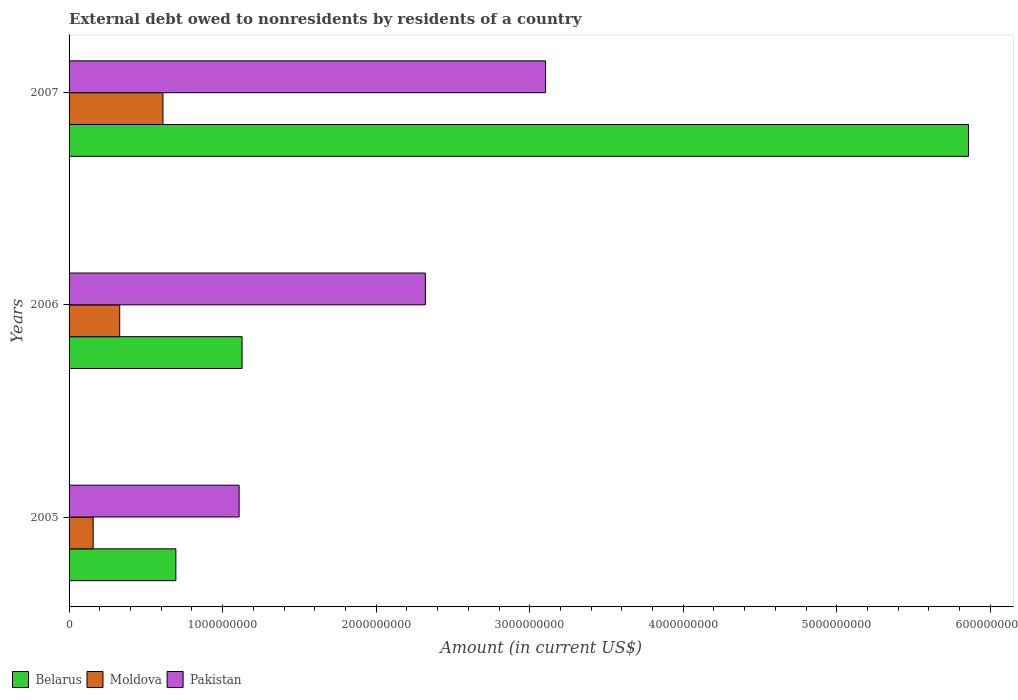Are the number of bars per tick equal to the number of legend labels?
Keep it short and to the point. Yes. Are the number of bars on each tick of the Y-axis equal?
Your answer should be very brief. Yes. How many bars are there on the 3rd tick from the bottom?
Your response must be concise. 3. What is the label of the 2nd group of bars from the top?
Ensure brevity in your answer.  2006. In how many cases, is the number of bars for a given year not equal to the number of legend labels?
Provide a short and direct response. 0. What is the external debt owed by residents in Moldova in 2006?
Give a very brief answer. 3.30e+08. Across all years, what is the maximum external debt owed by residents in Belarus?
Offer a very short reply. 5.86e+09. Across all years, what is the minimum external debt owed by residents in Belarus?
Offer a very short reply. 6.96e+08. What is the total external debt owed by residents in Pakistan in the graph?
Keep it short and to the point. 6.53e+09. What is the difference between the external debt owed by residents in Belarus in 2005 and that in 2006?
Provide a short and direct response. -4.31e+08. What is the difference between the external debt owed by residents in Pakistan in 2005 and the external debt owed by residents in Moldova in 2007?
Give a very brief answer. 4.96e+08. What is the average external debt owed by residents in Moldova per year?
Ensure brevity in your answer.  3.66e+08. In the year 2006, what is the difference between the external debt owed by residents in Belarus and external debt owed by residents in Moldova?
Your response must be concise. 7.97e+08. What is the ratio of the external debt owed by residents in Pakistan in 2005 to that in 2006?
Your response must be concise. 0.48. What is the difference between the highest and the second highest external debt owed by residents in Moldova?
Your answer should be very brief. 2.82e+08. What is the difference between the highest and the lowest external debt owed by residents in Moldova?
Give a very brief answer. 4.54e+08. What does the 2nd bar from the top in 2006 represents?
Give a very brief answer. Moldova. What does the 1st bar from the bottom in 2006 represents?
Provide a succinct answer. Belarus. Is it the case that in every year, the sum of the external debt owed by residents in Moldova and external debt owed by residents in Pakistan is greater than the external debt owed by residents in Belarus?
Offer a terse response. No. Are all the bars in the graph horizontal?
Ensure brevity in your answer.  Yes. What is the difference between two consecutive major ticks on the X-axis?
Ensure brevity in your answer.  1.00e+09. Where does the legend appear in the graph?
Your answer should be compact. Bottom left. How many legend labels are there?
Make the answer very short. 3. How are the legend labels stacked?
Keep it short and to the point. Horizontal. What is the title of the graph?
Ensure brevity in your answer.  External debt owed to nonresidents by residents of a country. What is the Amount (in current US$) in Belarus in 2005?
Ensure brevity in your answer.  6.96e+08. What is the Amount (in current US$) of Moldova in 2005?
Your response must be concise. 1.57e+08. What is the Amount (in current US$) in Pakistan in 2005?
Your response must be concise. 1.11e+09. What is the Amount (in current US$) of Belarus in 2006?
Give a very brief answer. 1.13e+09. What is the Amount (in current US$) of Moldova in 2006?
Offer a terse response. 3.30e+08. What is the Amount (in current US$) in Pakistan in 2006?
Provide a short and direct response. 2.32e+09. What is the Amount (in current US$) of Belarus in 2007?
Keep it short and to the point. 5.86e+09. What is the Amount (in current US$) in Moldova in 2007?
Keep it short and to the point. 6.11e+08. What is the Amount (in current US$) of Pakistan in 2007?
Give a very brief answer. 3.10e+09. Across all years, what is the maximum Amount (in current US$) of Belarus?
Offer a very short reply. 5.86e+09. Across all years, what is the maximum Amount (in current US$) in Moldova?
Your answer should be very brief. 6.11e+08. Across all years, what is the maximum Amount (in current US$) in Pakistan?
Make the answer very short. 3.10e+09. Across all years, what is the minimum Amount (in current US$) of Belarus?
Provide a succinct answer. 6.96e+08. Across all years, what is the minimum Amount (in current US$) in Moldova?
Provide a short and direct response. 1.57e+08. Across all years, what is the minimum Amount (in current US$) in Pakistan?
Offer a very short reply. 1.11e+09. What is the total Amount (in current US$) of Belarus in the graph?
Provide a succinct answer. 7.68e+09. What is the total Amount (in current US$) in Moldova in the graph?
Ensure brevity in your answer.  1.10e+09. What is the total Amount (in current US$) in Pakistan in the graph?
Keep it short and to the point. 6.53e+09. What is the difference between the Amount (in current US$) in Belarus in 2005 and that in 2006?
Provide a short and direct response. -4.31e+08. What is the difference between the Amount (in current US$) in Moldova in 2005 and that in 2006?
Offer a terse response. -1.73e+08. What is the difference between the Amount (in current US$) of Pakistan in 2005 and that in 2006?
Offer a very short reply. -1.21e+09. What is the difference between the Amount (in current US$) in Belarus in 2005 and that in 2007?
Offer a terse response. -5.16e+09. What is the difference between the Amount (in current US$) in Moldova in 2005 and that in 2007?
Provide a succinct answer. -4.54e+08. What is the difference between the Amount (in current US$) in Pakistan in 2005 and that in 2007?
Offer a terse response. -2.00e+09. What is the difference between the Amount (in current US$) of Belarus in 2006 and that in 2007?
Make the answer very short. -4.73e+09. What is the difference between the Amount (in current US$) in Moldova in 2006 and that in 2007?
Keep it short and to the point. -2.82e+08. What is the difference between the Amount (in current US$) in Pakistan in 2006 and that in 2007?
Offer a very short reply. -7.83e+08. What is the difference between the Amount (in current US$) in Belarus in 2005 and the Amount (in current US$) in Moldova in 2006?
Offer a terse response. 3.66e+08. What is the difference between the Amount (in current US$) in Belarus in 2005 and the Amount (in current US$) in Pakistan in 2006?
Provide a succinct answer. -1.62e+09. What is the difference between the Amount (in current US$) in Moldova in 2005 and the Amount (in current US$) in Pakistan in 2006?
Offer a very short reply. -2.16e+09. What is the difference between the Amount (in current US$) in Belarus in 2005 and the Amount (in current US$) in Moldova in 2007?
Offer a very short reply. 8.43e+07. What is the difference between the Amount (in current US$) of Belarus in 2005 and the Amount (in current US$) of Pakistan in 2007?
Your answer should be compact. -2.41e+09. What is the difference between the Amount (in current US$) of Moldova in 2005 and the Amount (in current US$) of Pakistan in 2007?
Provide a succinct answer. -2.95e+09. What is the difference between the Amount (in current US$) of Belarus in 2006 and the Amount (in current US$) of Moldova in 2007?
Ensure brevity in your answer.  5.15e+08. What is the difference between the Amount (in current US$) in Belarus in 2006 and the Amount (in current US$) in Pakistan in 2007?
Make the answer very short. -1.98e+09. What is the difference between the Amount (in current US$) in Moldova in 2006 and the Amount (in current US$) in Pakistan in 2007?
Offer a very short reply. -2.77e+09. What is the average Amount (in current US$) in Belarus per year?
Offer a very short reply. 2.56e+09. What is the average Amount (in current US$) of Moldova per year?
Offer a very short reply. 3.66e+08. What is the average Amount (in current US$) of Pakistan per year?
Your answer should be compact. 2.18e+09. In the year 2005, what is the difference between the Amount (in current US$) of Belarus and Amount (in current US$) of Moldova?
Give a very brief answer. 5.39e+08. In the year 2005, what is the difference between the Amount (in current US$) in Belarus and Amount (in current US$) in Pakistan?
Provide a succinct answer. -4.12e+08. In the year 2005, what is the difference between the Amount (in current US$) in Moldova and Amount (in current US$) in Pakistan?
Your response must be concise. -9.51e+08. In the year 2006, what is the difference between the Amount (in current US$) in Belarus and Amount (in current US$) in Moldova?
Your answer should be very brief. 7.97e+08. In the year 2006, what is the difference between the Amount (in current US$) in Belarus and Amount (in current US$) in Pakistan?
Your answer should be very brief. -1.19e+09. In the year 2006, what is the difference between the Amount (in current US$) of Moldova and Amount (in current US$) of Pakistan?
Ensure brevity in your answer.  -1.99e+09. In the year 2007, what is the difference between the Amount (in current US$) of Belarus and Amount (in current US$) of Moldova?
Give a very brief answer. 5.25e+09. In the year 2007, what is the difference between the Amount (in current US$) in Belarus and Amount (in current US$) in Pakistan?
Ensure brevity in your answer.  2.75e+09. In the year 2007, what is the difference between the Amount (in current US$) in Moldova and Amount (in current US$) in Pakistan?
Offer a very short reply. -2.49e+09. What is the ratio of the Amount (in current US$) of Belarus in 2005 to that in 2006?
Make the answer very short. 0.62. What is the ratio of the Amount (in current US$) of Moldova in 2005 to that in 2006?
Make the answer very short. 0.48. What is the ratio of the Amount (in current US$) in Pakistan in 2005 to that in 2006?
Give a very brief answer. 0.48. What is the ratio of the Amount (in current US$) of Belarus in 2005 to that in 2007?
Offer a terse response. 0.12. What is the ratio of the Amount (in current US$) in Moldova in 2005 to that in 2007?
Keep it short and to the point. 0.26. What is the ratio of the Amount (in current US$) of Pakistan in 2005 to that in 2007?
Offer a very short reply. 0.36. What is the ratio of the Amount (in current US$) of Belarus in 2006 to that in 2007?
Offer a terse response. 0.19. What is the ratio of the Amount (in current US$) of Moldova in 2006 to that in 2007?
Provide a short and direct response. 0.54. What is the ratio of the Amount (in current US$) in Pakistan in 2006 to that in 2007?
Give a very brief answer. 0.75. What is the difference between the highest and the second highest Amount (in current US$) of Belarus?
Ensure brevity in your answer.  4.73e+09. What is the difference between the highest and the second highest Amount (in current US$) of Moldova?
Offer a very short reply. 2.82e+08. What is the difference between the highest and the second highest Amount (in current US$) in Pakistan?
Give a very brief answer. 7.83e+08. What is the difference between the highest and the lowest Amount (in current US$) of Belarus?
Offer a terse response. 5.16e+09. What is the difference between the highest and the lowest Amount (in current US$) of Moldova?
Provide a short and direct response. 4.54e+08. What is the difference between the highest and the lowest Amount (in current US$) in Pakistan?
Provide a succinct answer. 2.00e+09. 